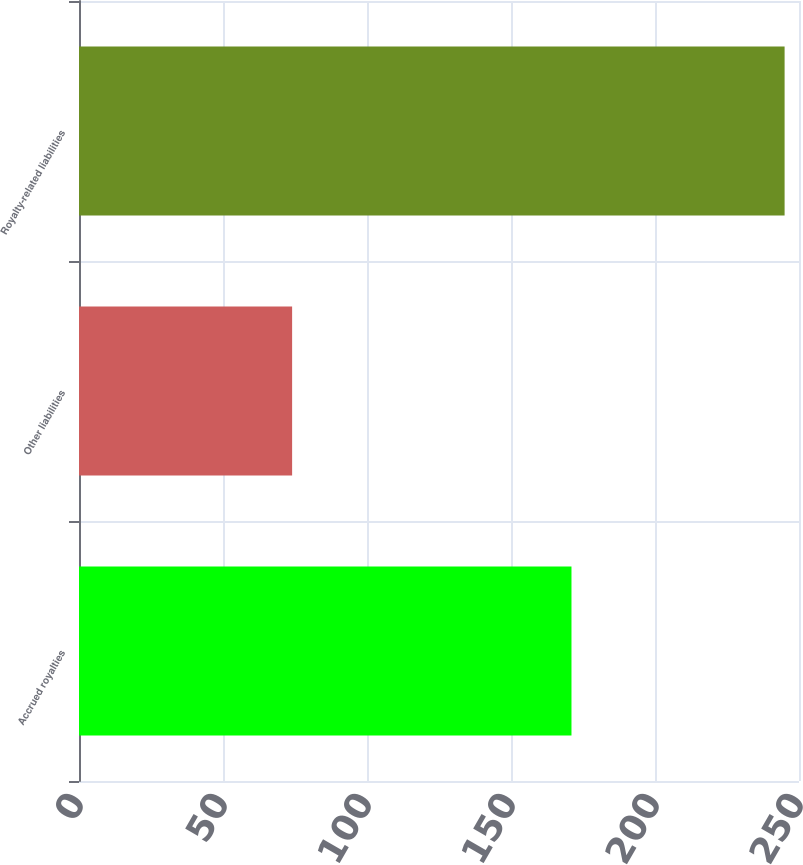<chart> <loc_0><loc_0><loc_500><loc_500><bar_chart><fcel>Accrued royalties<fcel>Other liabilities<fcel>Royalty-related liabilities<nl><fcel>171<fcel>74<fcel>245<nl></chart> 